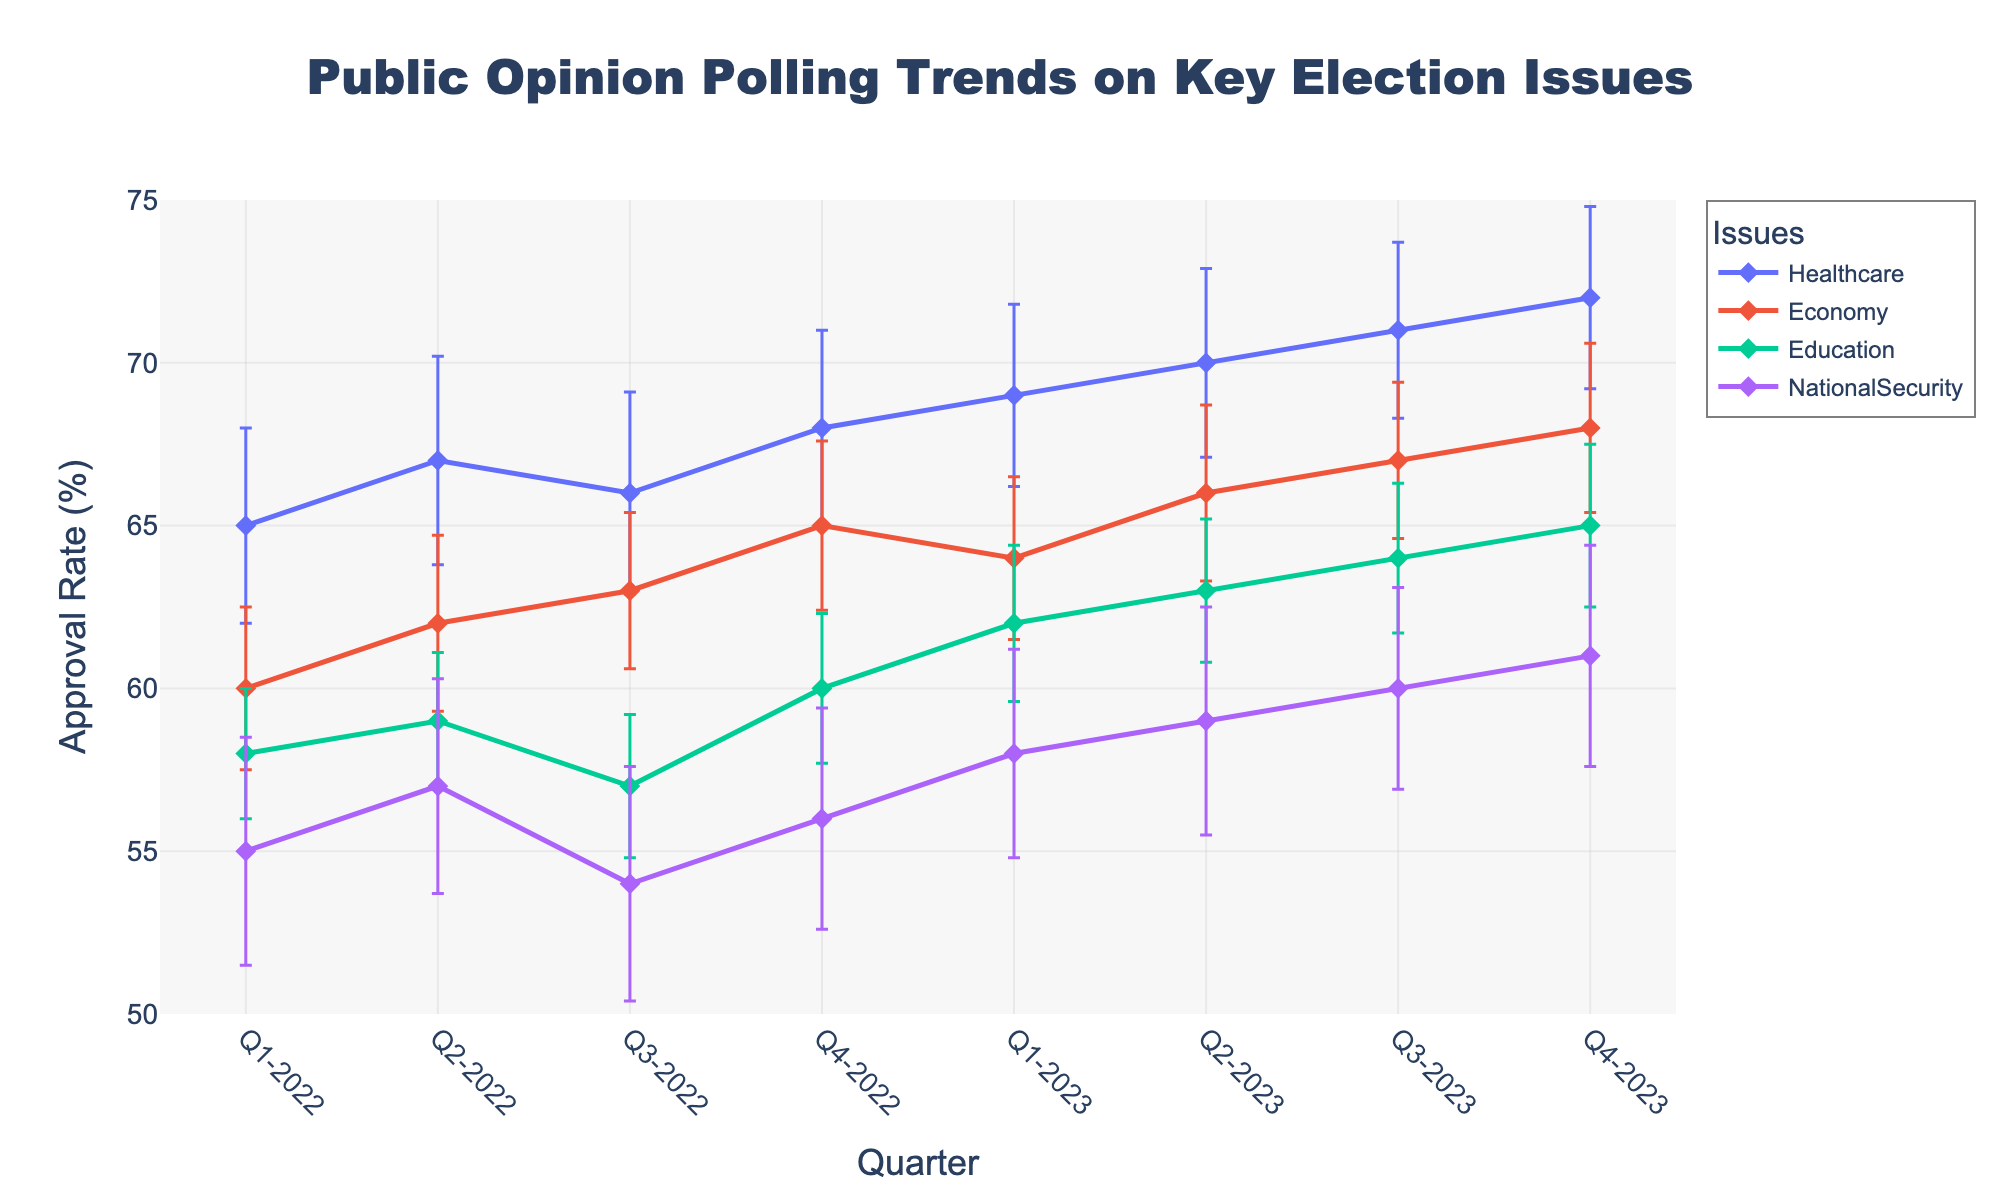Which issue had the highest approval rate in Q1-2023? By looking at Q1-2023 on the x-axis and comparing the approval rates for different issues, Healthcare has the highest value.
Answer: Healthcare How many quarters are represented in the figure? Count the unique quarters on the x-axis. They range from Q1-2022 to Q4-2023, making a total of eight quarters.
Answer: 8 Which issue saw the greatest increase in approval rate from Q2-2022 to Q4-2023? Compare the approval rates of each issue from Q2-2022 to Q4-2023. Healthcare increased from 67% to 72%, which is the largest increase of 5 percentage points.
Answer: Healthcare What's the average approval rate for Education over the entire period? Sum the approval rates for Education across all quarters and divide by the number of quarters (8). (58+59+57+60+62+63+64+65)/8 = 61
Answer: 61 In which quarter did the Economy issue experience the highest approval rate? Compare approval rates for the Economy issue across all quarters. The highest value is 68%, observed in Q4-2023.
Answer: Q4-2023 Are there any quarters where the approval rates for Healthcare and National Security intersect or overlap within their margin of error? Compare the approval rates and margin of error bars for Healthcare and National Security across all quarters to identify any intersections or overlaps. There is no intersection or overlap observed.
Answer: No Which issue had the most volatile approval rates, considering the margin of error? Volatility can be seen from both the approval rate fluctuation and large error bars. National Security displays the largest error bars and noticeable fluctuations.
Answer: National Security How did the approval rate for National Security change from Q4-2022 to Q2-2023? Observe National Security approval rates over Q4-2022 to Q2-2023. The rate increased from 56% to 59%.
Answer: Increased by 3% What's the difference in approval rate between Healthcare and Economy in Q3-2023? Subtract Economy's approval rate from Healthcare's approval rate for Q3-2023. 71 - 67 = 4
Answer: 4 Which issue had the lowest average margin of error over the entire period? Calculate and compare the average margin of error for each issue. Economy has the smallest average margin of error.
Answer: Economy 